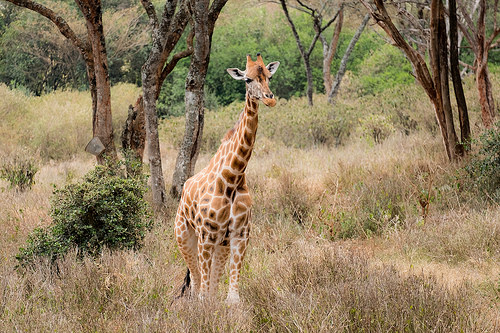<image>
Is the giraffe behind the tree? No. The giraffe is not behind the tree. From this viewpoint, the giraffe appears to be positioned elsewhere in the scene. 